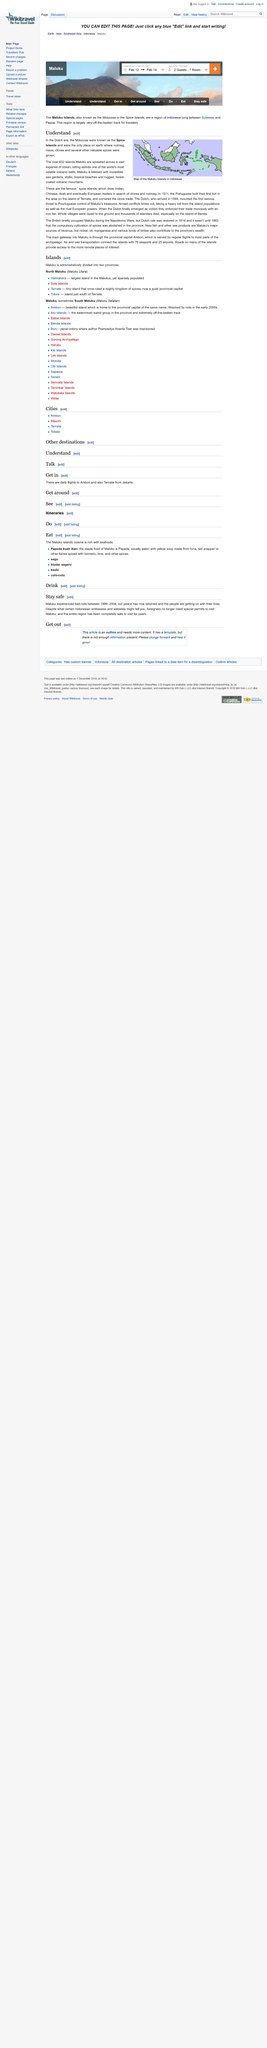Highlight a few significant elements in this photo. The Maluku Islands are home to a staggering 632 islands, sprawled across a vast expanse of the ocean. The Moluccas were known as the Spice Islands during the Dutch era because they were the only place on earth where nutmeg, mace, cloves, and several other valuable spices were grown. The Maluku Islands are located in Indonesia. 